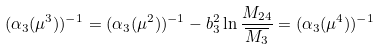Convert formula to latex. <formula><loc_0><loc_0><loc_500><loc_500>( \alpha _ { 3 } ( \mu ^ { 3 } ) ) ^ { - 1 } = ( \alpha _ { 3 } ( \mu ^ { 2 } ) ) ^ { - 1 } - b _ { 3 } ^ { 2 } \ln \frac { M _ { 2 4 } } { \overline { M _ { 3 } } } = ( \alpha _ { 3 } ( \mu ^ { 4 } ) ) ^ { - 1 }</formula> 